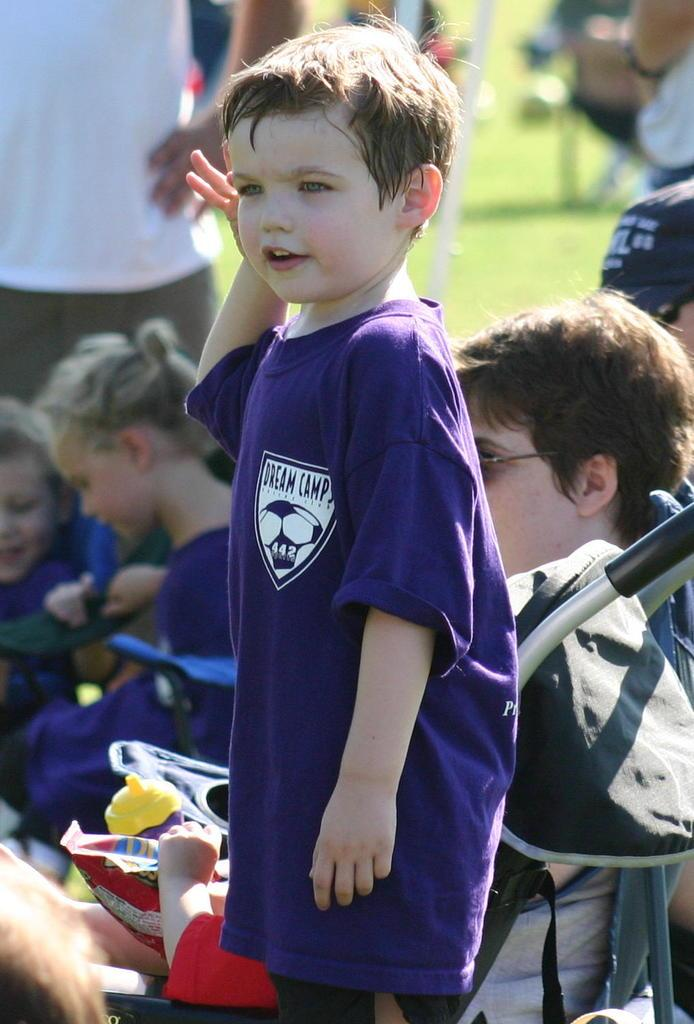What is the main subject of the image? The main subject of the image is a boy standing. Can you describe what the boy is wearing? The boy is wearing a T-shirt. What are the other children in the image doing? The other children are sitting in the image. What object related to babies or young children is present in the image? There is a stroller in the image. Can you describe the person in the background of the image? There is a person standing in the background of the image. What type of tomatoes can be seen growing in the image? There are no tomatoes present in the image. What is the relation between the boy and the person standing in the background of the image? The provided facts do not give any information about the relationship between the boy and the person standing in the background. 